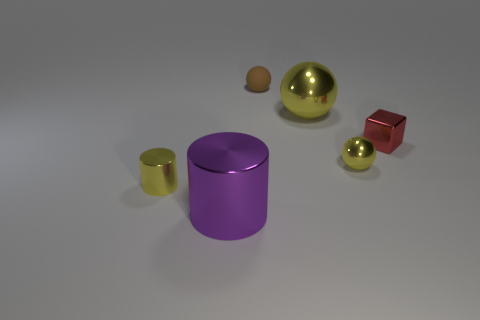What number of objects are either tiny things that are to the right of the brown thing or big purple metallic cylinders?
Keep it short and to the point. 3. What material is the brown object that is the same size as the red shiny thing?
Your response must be concise. Rubber. What color is the small shiny object that is on the left side of the metallic cylinder right of the small cylinder?
Ensure brevity in your answer.  Yellow. How many large things are to the left of the small yellow cylinder?
Provide a short and direct response. 0. What is the color of the metallic cube?
Provide a short and direct response. Red. How many small objects are either shiny spheres or brown shiny cubes?
Provide a short and direct response. 1. Do the small ball that is in front of the block and the metal sphere that is behind the red block have the same color?
Make the answer very short. Yes. What number of other things are there of the same color as the matte sphere?
Provide a succinct answer. 0. There is a big shiny thing in front of the small cylinder; what shape is it?
Provide a succinct answer. Cylinder. Are there fewer cylinders than small yellow metallic cylinders?
Provide a succinct answer. No. 